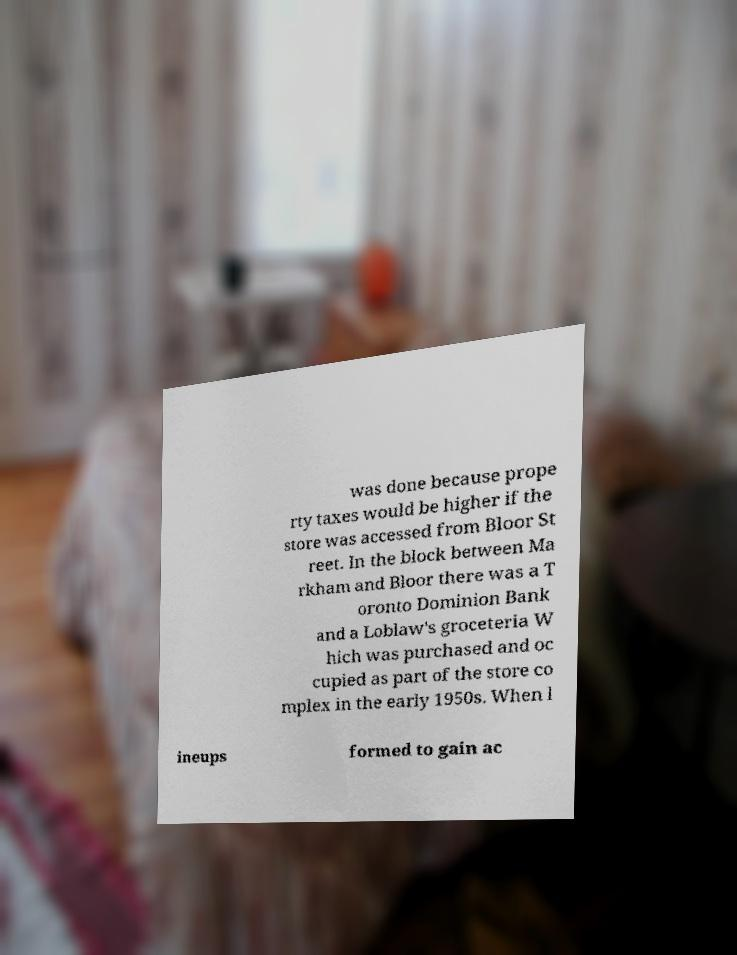I need the written content from this picture converted into text. Can you do that? was done because prope rty taxes would be higher if the store was accessed from Bloor St reet. In the block between Ma rkham and Bloor there was a T oronto Dominion Bank and a Loblaw's groceteria W hich was purchased and oc cupied as part of the store co mplex in the early 1950s. When l ineups formed to gain ac 